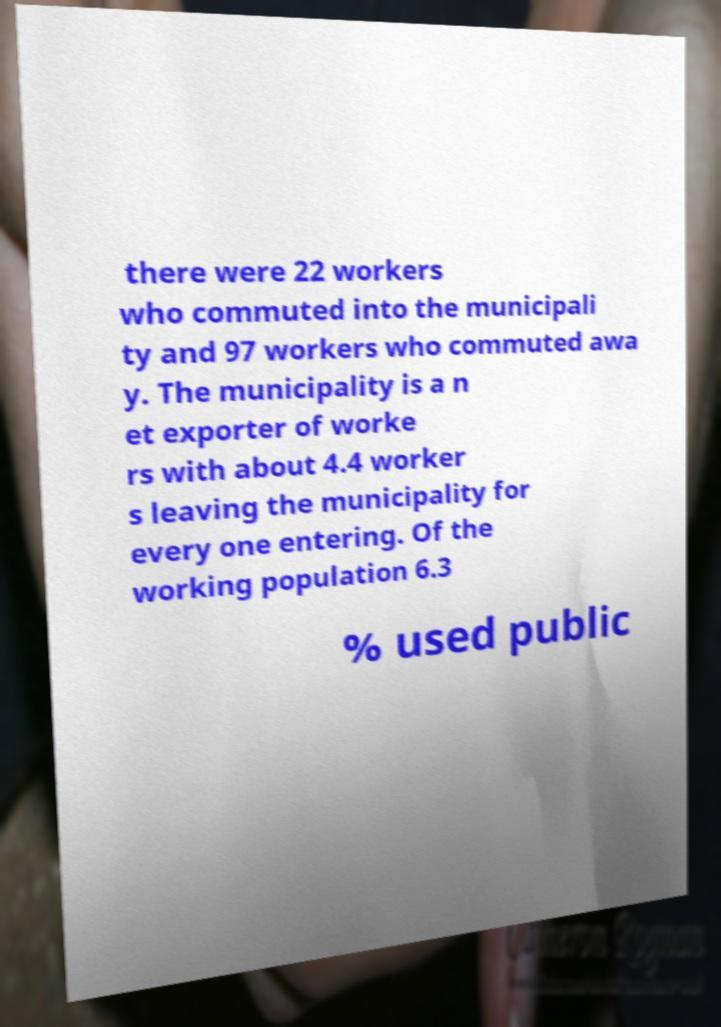I need the written content from this picture converted into text. Can you do that? there were 22 workers who commuted into the municipali ty and 97 workers who commuted awa y. The municipality is a n et exporter of worke rs with about 4.4 worker s leaving the municipality for every one entering. Of the working population 6.3 % used public 